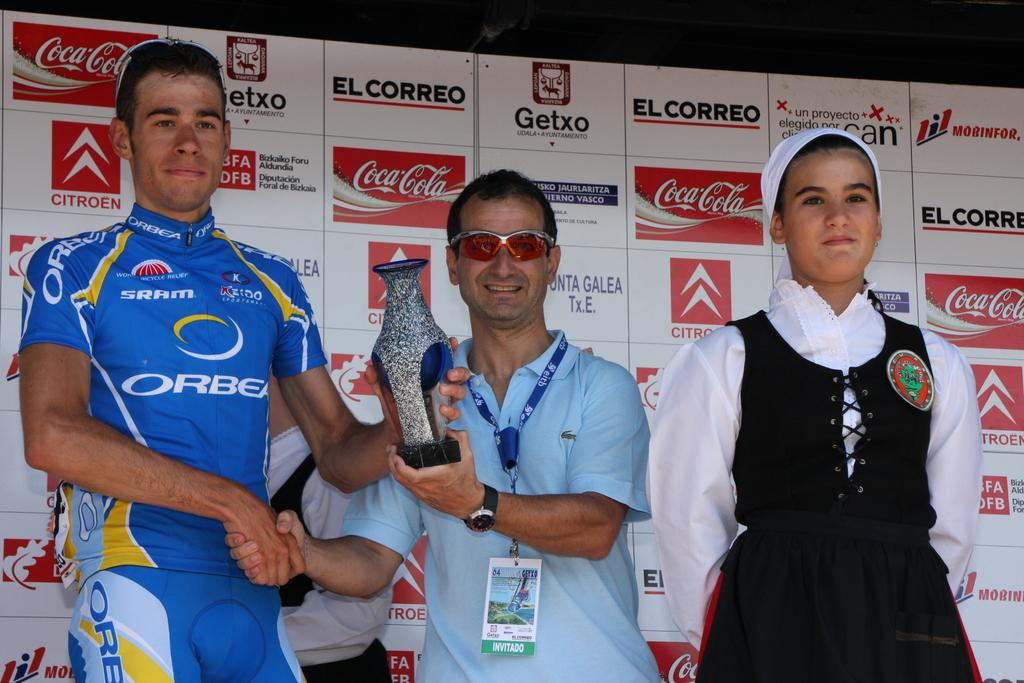<image>
Present a compact description of the photo's key features. A man is being handed a trophy in front of several coca cola adverts. 